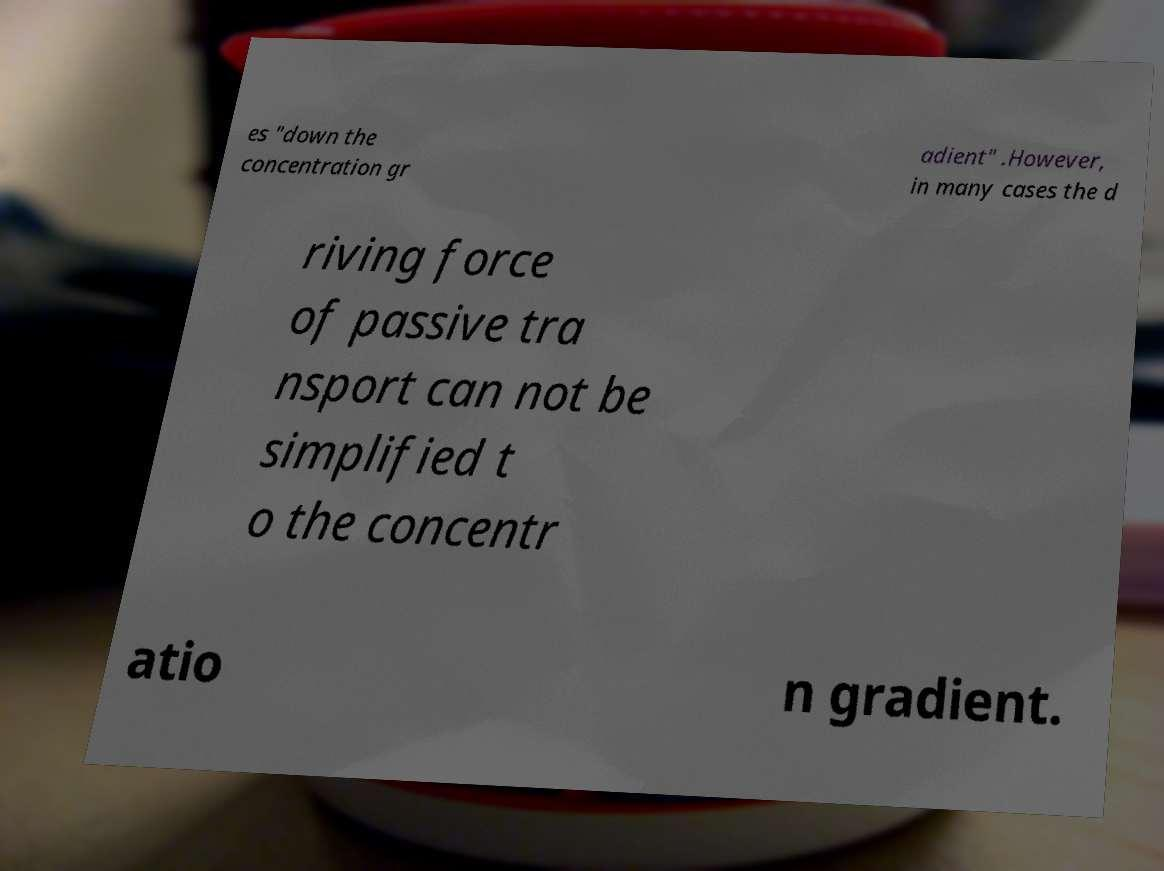Could you extract and type out the text from this image? es "down the concentration gr adient" .However, in many cases the d riving force of passive tra nsport can not be simplified t o the concentr atio n gradient. 